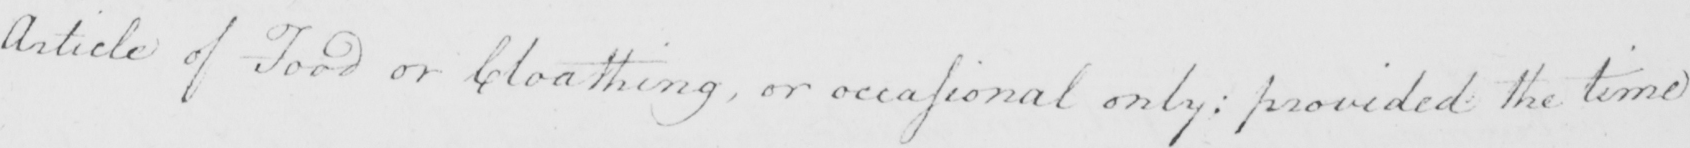What is written in this line of handwriting? Article of Food or Cloathing  , or occasional only :  provided the time 